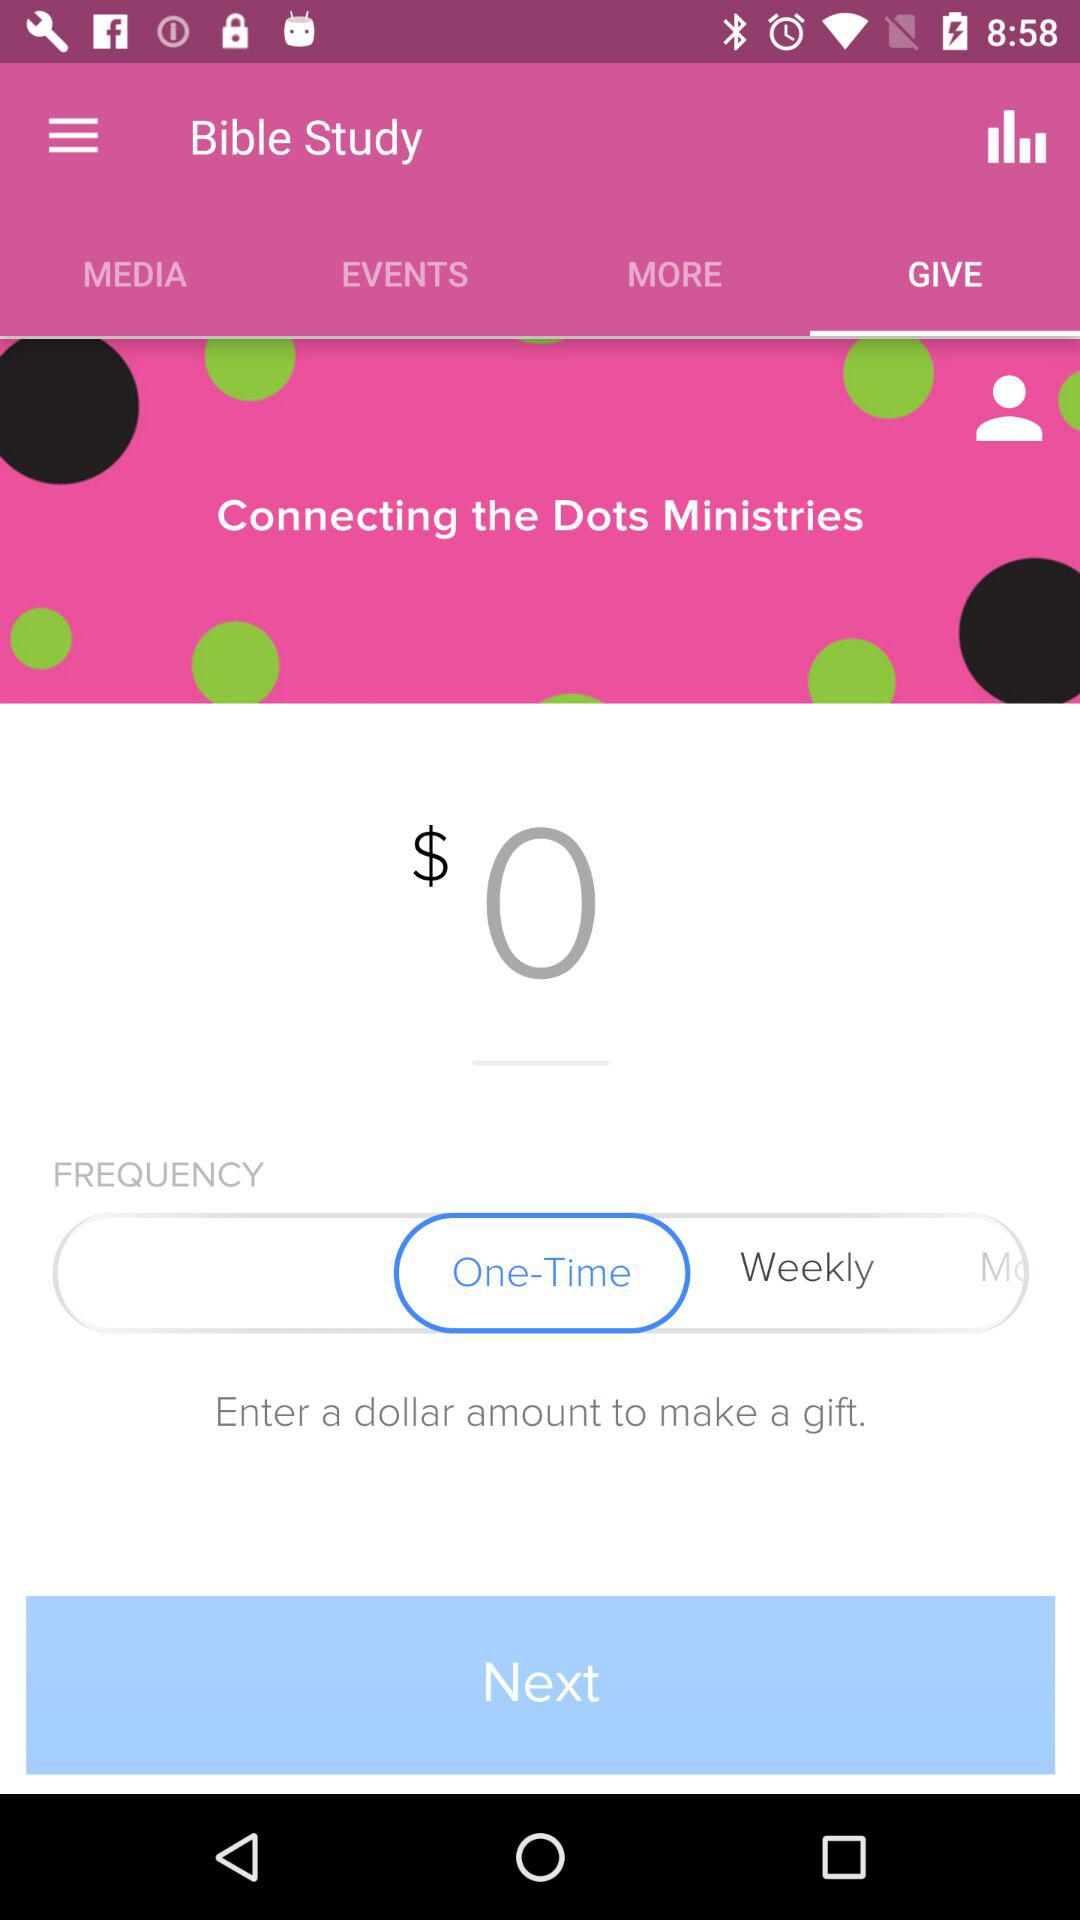What is the currency for the entered amount? The currency for the entered amount is dollars. 